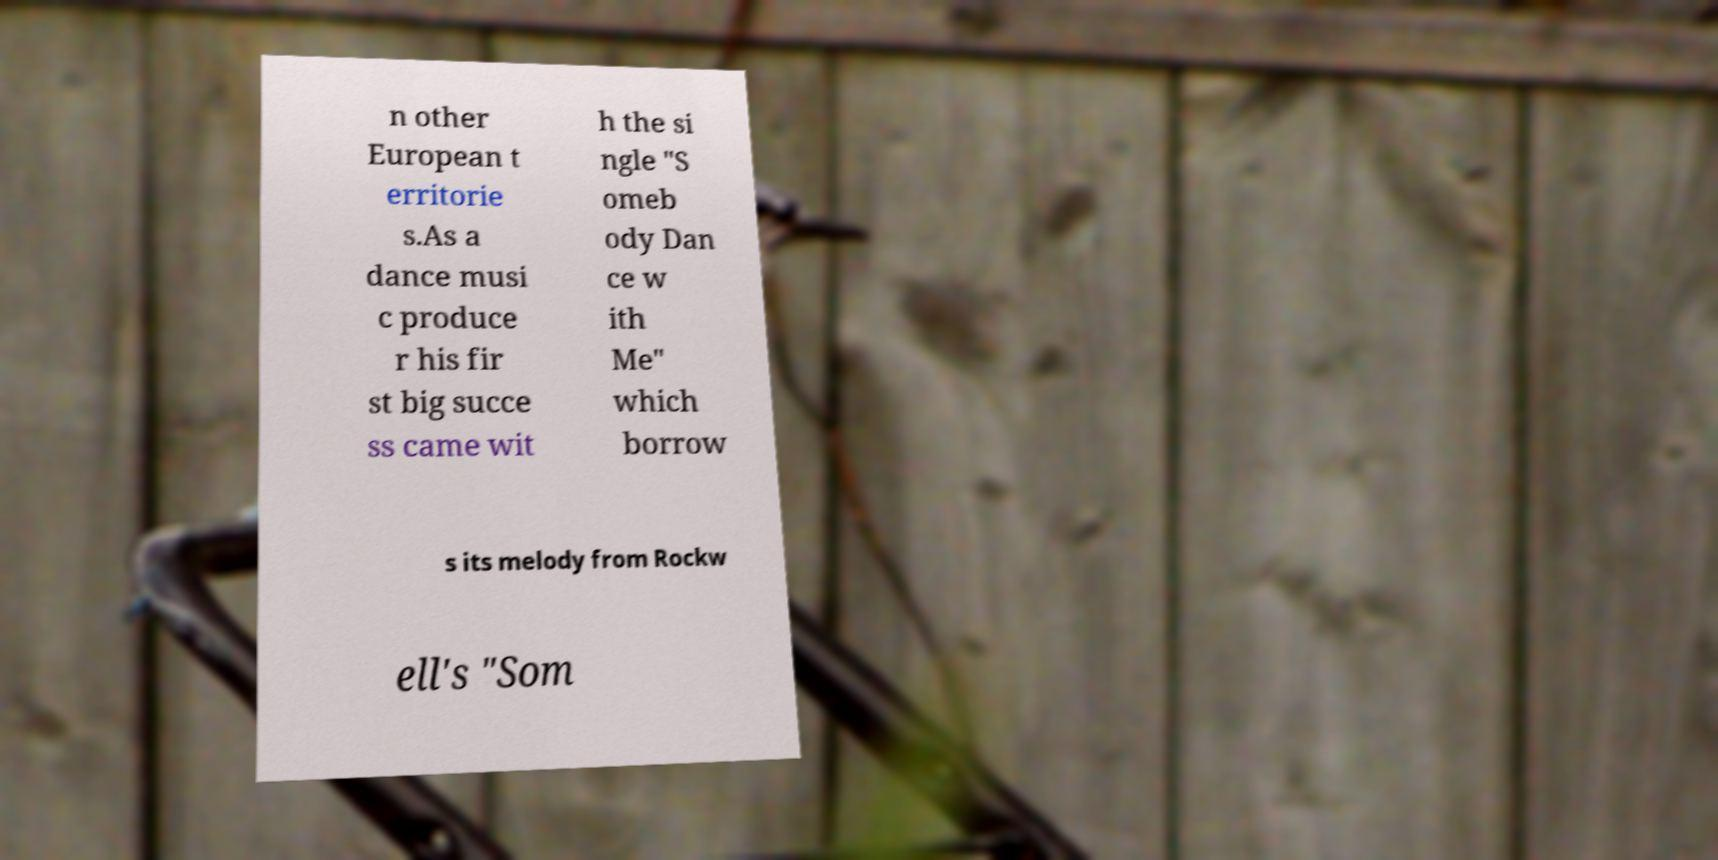There's text embedded in this image that I need extracted. Can you transcribe it verbatim? n other European t erritorie s.As a dance musi c produce r his fir st big succe ss came wit h the si ngle "S omeb ody Dan ce w ith Me" which borrow s its melody from Rockw ell's "Som 